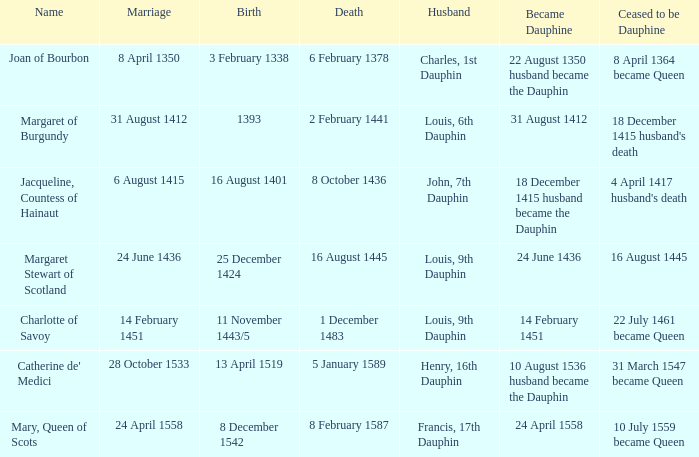When was the death when the birth was 8 december 1542? 8 February 1587. 